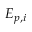Convert formula to latex. <formula><loc_0><loc_0><loc_500><loc_500>E _ { p , i }</formula> 